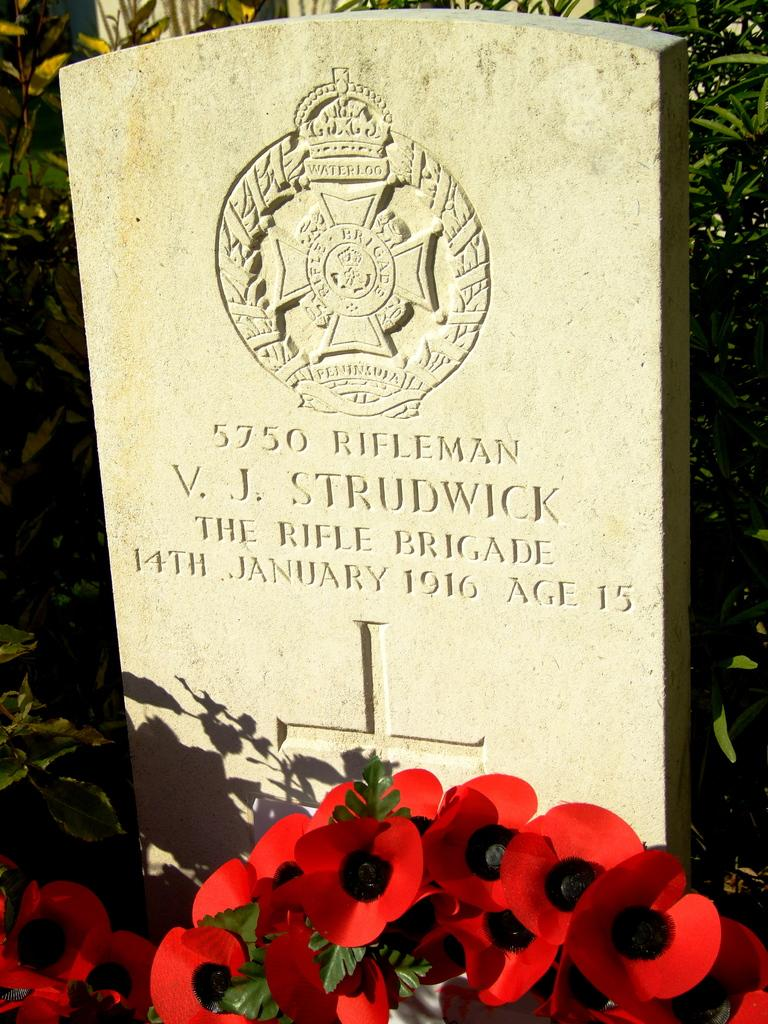What is written or depicted on the grave in the image? There is text on a grave in the image, and there are carvings on the grave. What type of flowers are placed in front of the grave? There are red flowers in front of the grave. What can be seen in the background of the image? There are green plants in the background of the image. What invention is being demonstrated by the deer in the image? There is no deer present in the image, and therefore no invention can be demonstrated. 